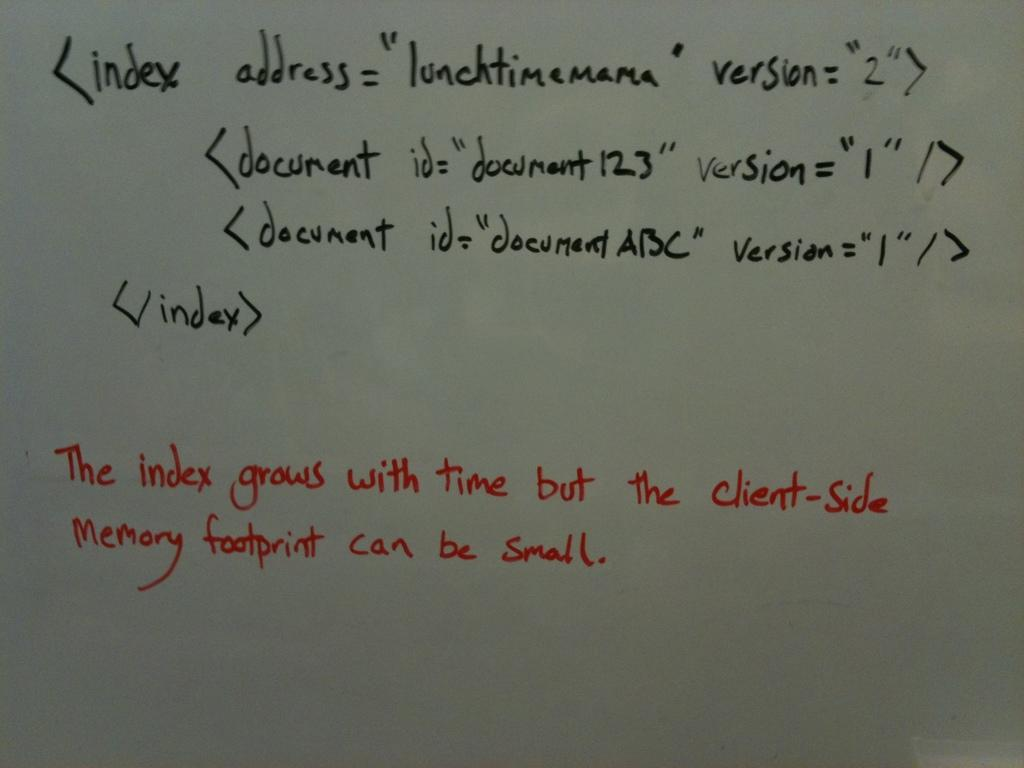<image>
Provide a brief description of the given image. The red text on the white board says the index grows with time. 